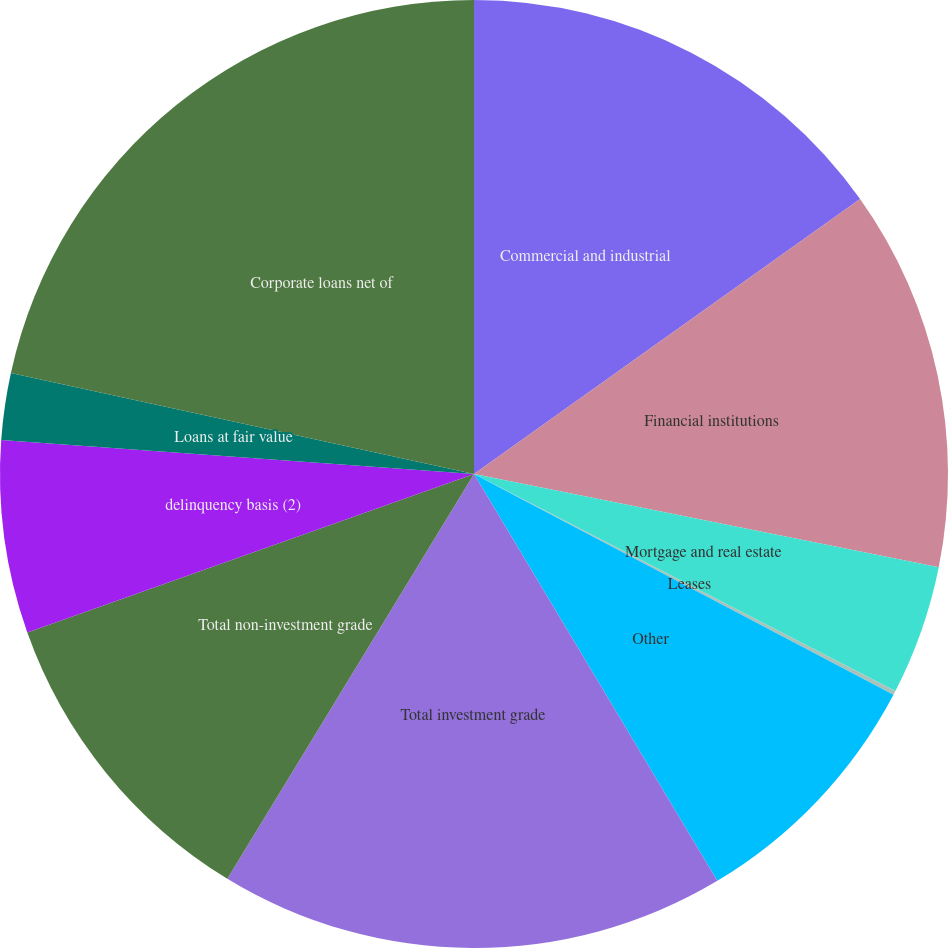<chart> <loc_0><loc_0><loc_500><loc_500><pie_chart><fcel>Commercial and industrial<fcel>Financial institutions<fcel>Mortgage and real estate<fcel>Leases<fcel>Other<fcel>Total investment grade<fcel>Total non-investment grade<fcel>delinquency basis (2)<fcel>Loans at fair value<fcel>Corporate loans net of<nl><fcel>15.15%<fcel>13.0%<fcel>4.42%<fcel>0.14%<fcel>8.71%<fcel>17.29%<fcel>10.86%<fcel>6.57%<fcel>2.28%<fcel>21.58%<nl></chart> 